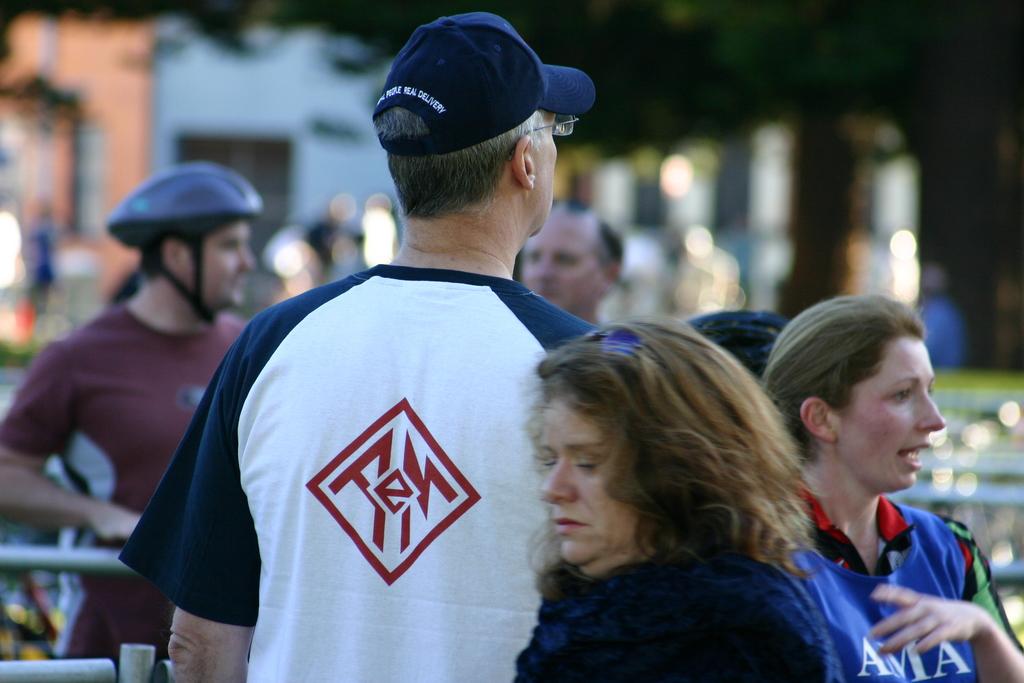What does the acronym on her shirt mean?
Your answer should be compact. Unanswerable. What is the last word on the back of the man's hat?
Your response must be concise. Delivery. 